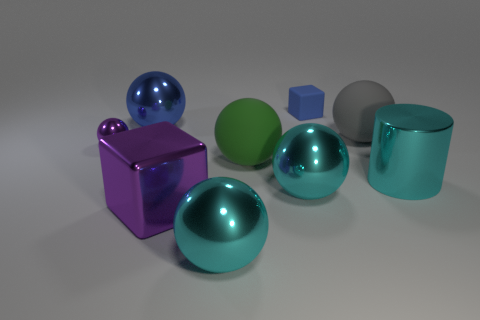Subtract all big cyan spheres. How many spheres are left? 4 Subtract all blue balls. How many balls are left? 5 Subtract all red balls. Subtract all blue cubes. How many balls are left? 6 Add 1 large blue balls. How many objects exist? 10 Subtract all large purple blocks. Subtract all big cyan spheres. How many objects are left? 6 Add 1 metallic things. How many metallic things are left? 7 Add 6 small gray spheres. How many small gray spheres exist? 6 Subtract 1 blue balls. How many objects are left? 8 Subtract all spheres. How many objects are left? 3 